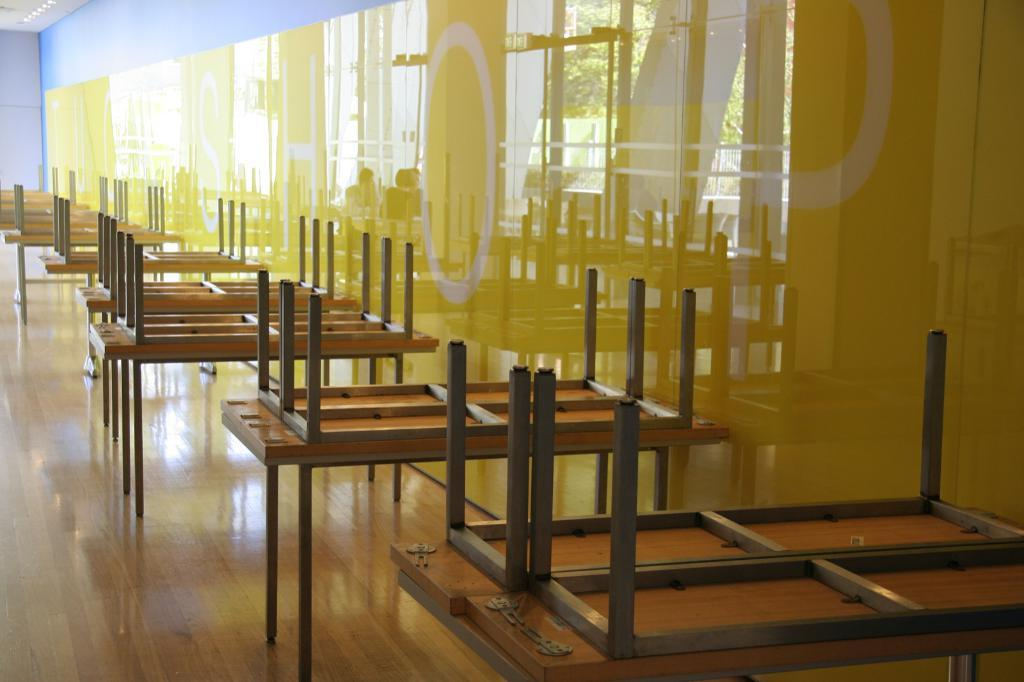What type of view is shown in the image? The image is an inside view. What can be seen on the floor in the image? There are tables on the floor in the image. What is visible on the walls in the image? There is a wall visible in the image. How does the image show respect to the audience? The image does not show respect to the audience, as it is a still image and not an interactive medium. 